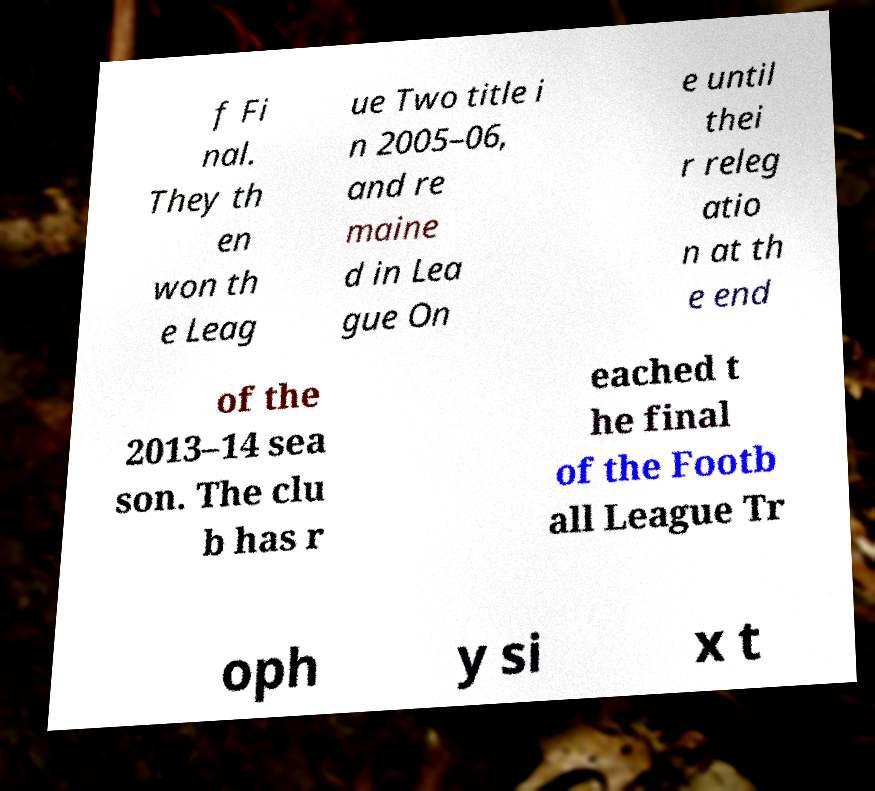Please read and relay the text visible in this image. What does it say? f Fi nal. They th en won th e Leag ue Two title i n 2005–06, and re maine d in Lea gue On e until thei r releg atio n at th e end of the 2013–14 sea son. The clu b has r eached t he final of the Footb all League Tr oph y si x t 